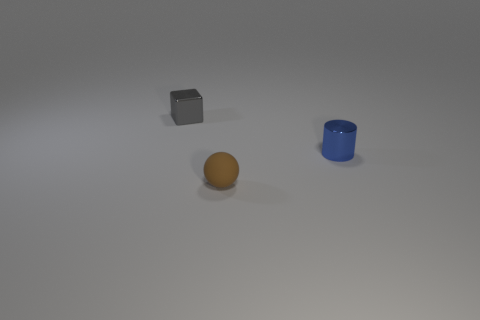Add 1 gray metallic cubes. How many objects exist? 4 Subtract all cubes. How many objects are left? 2 Subtract all small gray blocks. Subtract all small blue cylinders. How many objects are left? 1 Add 2 blue shiny cylinders. How many blue shiny cylinders are left? 3 Add 1 spheres. How many spheres exist? 2 Subtract 0 purple cylinders. How many objects are left? 3 